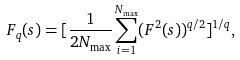Convert formula to latex. <formula><loc_0><loc_0><loc_500><loc_500>F _ { q } ( s ) = [ \frac { 1 } { 2 N _ { \max } } \sum _ { i = 1 } ^ { N _ { \max } } ( F ^ { 2 } ( s ) ) ^ { q / 2 } ] ^ { 1 / q } ,</formula> 